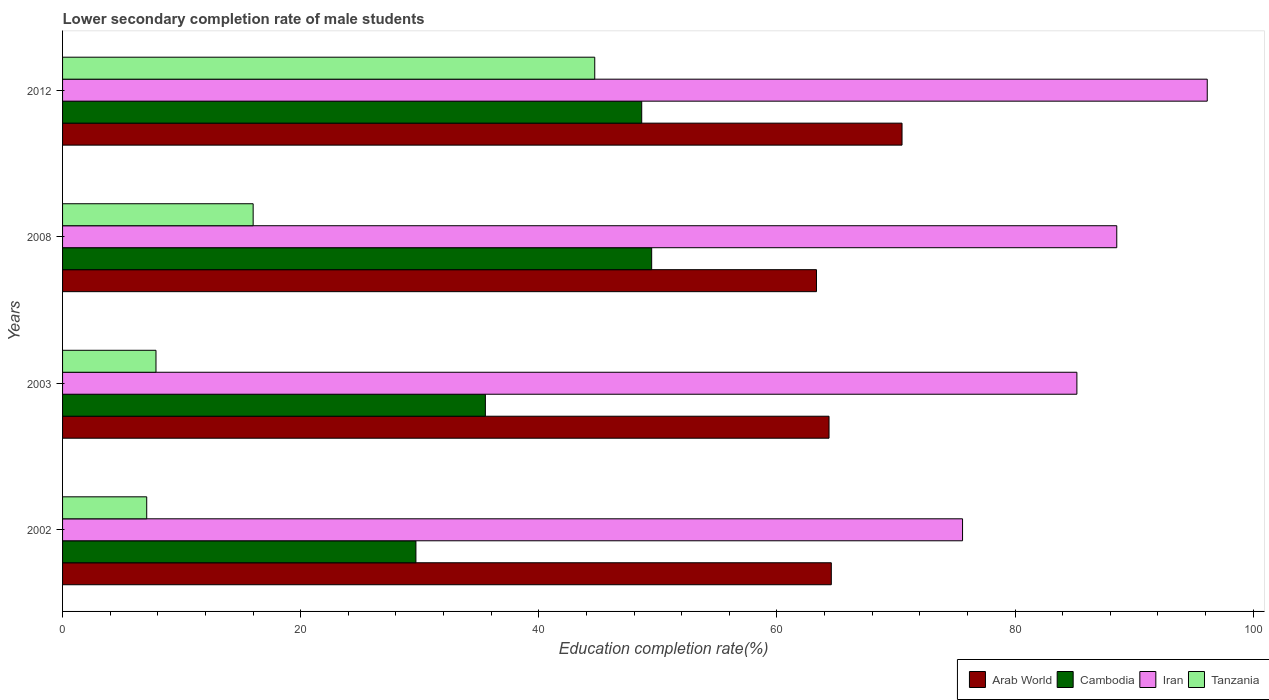Are the number of bars per tick equal to the number of legend labels?
Provide a succinct answer. Yes. How many bars are there on the 1st tick from the top?
Give a very brief answer. 4. How many bars are there on the 1st tick from the bottom?
Provide a succinct answer. 4. What is the label of the 3rd group of bars from the top?
Your answer should be compact. 2003. In how many cases, is the number of bars for a given year not equal to the number of legend labels?
Provide a succinct answer. 0. What is the lower secondary completion rate of male students in Cambodia in 2002?
Make the answer very short. 29.68. Across all years, what is the maximum lower secondary completion rate of male students in Iran?
Your answer should be compact. 96.14. Across all years, what is the minimum lower secondary completion rate of male students in Cambodia?
Provide a succinct answer. 29.68. In which year was the lower secondary completion rate of male students in Arab World minimum?
Ensure brevity in your answer.  2008. What is the total lower secondary completion rate of male students in Tanzania in the graph?
Keep it short and to the point. 75.62. What is the difference between the lower secondary completion rate of male students in Tanzania in 2003 and that in 2008?
Give a very brief answer. -8.16. What is the difference between the lower secondary completion rate of male students in Cambodia in 2012 and the lower secondary completion rate of male students in Iran in 2002?
Your answer should be compact. -26.95. What is the average lower secondary completion rate of male students in Iran per year?
Provide a short and direct response. 86.37. In the year 2008, what is the difference between the lower secondary completion rate of male students in Arab World and lower secondary completion rate of male students in Tanzania?
Offer a terse response. 47.31. What is the ratio of the lower secondary completion rate of male students in Iran in 2003 to that in 2008?
Keep it short and to the point. 0.96. What is the difference between the highest and the second highest lower secondary completion rate of male students in Tanzania?
Your answer should be compact. 28.69. What is the difference between the highest and the lowest lower secondary completion rate of male students in Iran?
Your answer should be compact. 20.55. Is it the case that in every year, the sum of the lower secondary completion rate of male students in Iran and lower secondary completion rate of male students in Arab World is greater than the sum of lower secondary completion rate of male students in Tanzania and lower secondary completion rate of male students in Cambodia?
Your answer should be compact. Yes. What does the 4th bar from the top in 2002 represents?
Ensure brevity in your answer.  Arab World. What does the 3rd bar from the bottom in 2003 represents?
Offer a terse response. Iran. How many bars are there?
Your answer should be very brief. 16. Are all the bars in the graph horizontal?
Offer a terse response. Yes. Does the graph contain any zero values?
Offer a terse response. No. Does the graph contain grids?
Give a very brief answer. No. Where does the legend appear in the graph?
Ensure brevity in your answer.  Bottom right. How are the legend labels stacked?
Ensure brevity in your answer.  Horizontal. What is the title of the graph?
Provide a succinct answer. Lower secondary completion rate of male students. Does "Pacific island small states" appear as one of the legend labels in the graph?
Provide a short and direct response. No. What is the label or title of the X-axis?
Your response must be concise. Education completion rate(%). What is the label or title of the Y-axis?
Offer a terse response. Years. What is the Education completion rate(%) in Arab World in 2002?
Give a very brief answer. 64.57. What is the Education completion rate(%) of Cambodia in 2002?
Offer a terse response. 29.68. What is the Education completion rate(%) in Iran in 2002?
Provide a short and direct response. 75.59. What is the Education completion rate(%) of Tanzania in 2002?
Offer a terse response. 7.07. What is the Education completion rate(%) in Arab World in 2003?
Your answer should be compact. 64.37. What is the Education completion rate(%) in Cambodia in 2003?
Offer a terse response. 35.51. What is the Education completion rate(%) of Iran in 2003?
Provide a succinct answer. 85.19. What is the Education completion rate(%) of Tanzania in 2003?
Provide a succinct answer. 7.85. What is the Education completion rate(%) in Arab World in 2008?
Offer a very short reply. 63.32. What is the Education completion rate(%) of Cambodia in 2008?
Your answer should be very brief. 49.48. What is the Education completion rate(%) of Iran in 2008?
Offer a terse response. 88.54. What is the Education completion rate(%) in Tanzania in 2008?
Make the answer very short. 16.01. What is the Education completion rate(%) in Arab World in 2012?
Ensure brevity in your answer.  70.51. What is the Education completion rate(%) of Cambodia in 2012?
Make the answer very short. 48.64. What is the Education completion rate(%) in Iran in 2012?
Provide a succinct answer. 96.14. What is the Education completion rate(%) in Tanzania in 2012?
Keep it short and to the point. 44.7. Across all years, what is the maximum Education completion rate(%) of Arab World?
Provide a succinct answer. 70.51. Across all years, what is the maximum Education completion rate(%) of Cambodia?
Make the answer very short. 49.48. Across all years, what is the maximum Education completion rate(%) of Iran?
Your answer should be very brief. 96.14. Across all years, what is the maximum Education completion rate(%) of Tanzania?
Your answer should be very brief. 44.7. Across all years, what is the minimum Education completion rate(%) in Arab World?
Your answer should be compact. 63.32. Across all years, what is the minimum Education completion rate(%) in Cambodia?
Make the answer very short. 29.68. Across all years, what is the minimum Education completion rate(%) in Iran?
Make the answer very short. 75.59. Across all years, what is the minimum Education completion rate(%) of Tanzania?
Your response must be concise. 7.07. What is the total Education completion rate(%) in Arab World in the graph?
Provide a succinct answer. 262.77. What is the total Education completion rate(%) in Cambodia in the graph?
Ensure brevity in your answer.  163.31. What is the total Education completion rate(%) in Iran in the graph?
Make the answer very short. 345.46. What is the total Education completion rate(%) of Tanzania in the graph?
Provide a short and direct response. 75.62. What is the difference between the Education completion rate(%) of Arab World in 2002 and that in 2003?
Offer a very short reply. 0.19. What is the difference between the Education completion rate(%) of Cambodia in 2002 and that in 2003?
Provide a succinct answer. -5.83. What is the difference between the Education completion rate(%) in Iran in 2002 and that in 2003?
Give a very brief answer. -9.6. What is the difference between the Education completion rate(%) in Tanzania in 2002 and that in 2003?
Your answer should be compact. -0.78. What is the difference between the Education completion rate(%) of Arab World in 2002 and that in 2008?
Your answer should be compact. 1.25. What is the difference between the Education completion rate(%) of Cambodia in 2002 and that in 2008?
Keep it short and to the point. -19.8. What is the difference between the Education completion rate(%) of Iran in 2002 and that in 2008?
Your answer should be very brief. -12.95. What is the difference between the Education completion rate(%) of Tanzania in 2002 and that in 2008?
Your answer should be compact. -8.94. What is the difference between the Education completion rate(%) of Arab World in 2002 and that in 2012?
Ensure brevity in your answer.  -5.94. What is the difference between the Education completion rate(%) of Cambodia in 2002 and that in 2012?
Offer a terse response. -18.96. What is the difference between the Education completion rate(%) in Iran in 2002 and that in 2012?
Provide a succinct answer. -20.55. What is the difference between the Education completion rate(%) of Tanzania in 2002 and that in 2012?
Your answer should be compact. -37.63. What is the difference between the Education completion rate(%) in Arab World in 2003 and that in 2008?
Make the answer very short. 1.05. What is the difference between the Education completion rate(%) of Cambodia in 2003 and that in 2008?
Make the answer very short. -13.97. What is the difference between the Education completion rate(%) of Iran in 2003 and that in 2008?
Keep it short and to the point. -3.35. What is the difference between the Education completion rate(%) of Tanzania in 2003 and that in 2008?
Your response must be concise. -8.16. What is the difference between the Education completion rate(%) of Arab World in 2003 and that in 2012?
Give a very brief answer. -6.13. What is the difference between the Education completion rate(%) of Cambodia in 2003 and that in 2012?
Your answer should be very brief. -13.13. What is the difference between the Education completion rate(%) of Iran in 2003 and that in 2012?
Offer a very short reply. -10.95. What is the difference between the Education completion rate(%) in Tanzania in 2003 and that in 2012?
Your response must be concise. -36.85. What is the difference between the Education completion rate(%) in Arab World in 2008 and that in 2012?
Your response must be concise. -7.18. What is the difference between the Education completion rate(%) of Cambodia in 2008 and that in 2012?
Your answer should be compact. 0.84. What is the difference between the Education completion rate(%) in Iran in 2008 and that in 2012?
Give a very brief answer. -7.6. What is the difference between the Education completion rate(%) in Tanzania in 2008 and that in 2012?
Your answer should be very brief. -28.69. What is the difference between the Education completion rate(%) in Arab World in 2002 and the Education completion rate(%) in Cambodia in 2003?
Provide a succinct answer. 29.06. What is the difference between the Education completion rate(%) of Arab World in 2002 and the Education completion rate(%) of Iran in 2003?
Your answer should be very brief. -20.63. What is the difference between the Education completion rate(%) in Arab World in 2002 and the Education completion rate(%) in Tanzania in 2003?
Ensure brevity in your answer.  56.72. What is the difference between the Education completion rate(%) of Cambodia in 2002 and the Education completion rate(%) of Iran in 2003?
Give a very brief answer. -55.51. What is the difference between the Education completion rate(%) in Cambodia in 2002 and the Education completion rate(%) in Tanzania in 2003?
Your answer should be compact. 21.83. What is the difference between the Education completion rate(%) in Iran in 2002 and the Education completion rate(%) in Tanzania in 2003?
Make the answer very short. 67.74. What is the difference between the Education completion rate(%) of Arab World in 2002 and the Education completion rate(%) of Cambodia in 2008?
Provide a succinct answer. 15.09. What is the difference between the Education completion rate(%) in Arab World in 2002 and the Education completion rate(%) in Iran in 2008?
Offer a very short reply. -23.98. What is the difference between the Education completion rate(%) of Arab World in 2002 and the Education completion rate(%) of Tanzania in 2008?
Your answer should be very brief. 48.56. What is the difference between the Education completion rate(%) in Cambodia in 2002 and the Education completion rate(%) in Iran in 2008?
Your response must be concise. -58.86. What is the difference between the Education completion rate(%) of Cambodia in 2002 and the Education completion rate(%) of Tanzania in 2008?
Offer a very short reply. 13.67. What is the difference between the Education completion rate(%) in Iran in 2002 and the Education completion rate(%) in Tanzania in 2008?
Provide a short and direct response. 59.58. What is the difference between the Education completion rate(%) in Arab World in 2002 and the Education completion rate(%) in Cambodia in 2012?
Ensure brevity in your answer.  15.92. What is the difference between the Education completion rate(%) of Arab World in 2002 and the Education completion rate(%) of Iran in 2012?
Offer a terse response. -31.58. What is the difference between the Education completion rate(%) in Arab World in 2002 and the Education completion rate(%) in Tanzania in 2012?
Provide a succinct answer. 19.87. What is the difference between the Education completion rate(%) of Cambodia in 2002 and the Education completion rate(%) of Iran in 2012?
Provide a short and direct response. -66.46. What is the difference between the Education completion rate(%) of Cambodia in 2002 and the Education completion rate(%) of Tanzania in 2012?
Offer a terse response. -15.02. What is the difference between the Education completion rate(%) in Iran in 2002 and the Education completion rate(%) in Tanzania in 2012?
Your answer should be very brief. 30.89. What is the difference between the Education completion rate(%) of Arab World in 2003 and the Education completion rate(%) of Cambodia in 2008?
Your answer should be very brief. 14.9. What is the difference between the Education completion rate(%) of Arab World in 2003 and the Education completion rate(%) of Iran in 2008?
Your response must be concise. -24.17. What is the difference between the Education completion rate(%) of Arab World in 2003 and the Education completion rate(%) of Tanzania in 2008?
Offer a very short reply. 48.37. What is the difference between the Education completion rate(%) in Cambodia in 2003 and the Education completion rate(%) in Iran in 2008?
Your response must be concise. -53.03. What is the difference between the Education completion rate(%) of Cambodia in 2003 and the Education completion rate(%) of Tanzania in 2008?
Keep it short and to the point. 19.5. What is the difference between the Education completion rate(%) of Iran in 2003 and the Education completion rate(%) of Tanzania in 2008?
Ensure brevity in your answer.  69.18. What is the difference between the Education completion rate(%) of Arab World in 2003 and the Education completion rate(%) of Cambodia in 2012?
Keep it short and to the point. 15.73. What is the difference between the Education completion rate(%) in Arab World in 2003 and the Education completion rate(%) in Iran in 2012?
Ensure brevity in your answer.  -31.77. What is the difference between the Education completion rate(%) of Arab World in 2003 and the Education completion rate(%) of Tanzania in 2012?
Your answer should be compact. 19.68. What is the difference between the Education completion rate(%) in Cambodia in 2003 and the Education completion rate(%) in Iran in 2012?
Ensure brevity in your answer.  -60.63. What is the difference between the Education completion rate(%) in Cambodia in 2003 and the Education completion rate(%) in Tanzania in 2012?
Give a very brief answer. -9.19. What is the difference between the Education completion rate(%) in Iran in 2003 and the Education completion rate(%) in Tanzania in 2012?
Provide a succinct answer. 40.49. What is the difference between the Education completion rate(%) in Arab World in 2008 and the Education completion rate(%) in Cambodia in 2012?
Your answer should be very brief. 14.68. What is the difference between the Education completion rate(%) in Arab World in 2008 and the Education completion rate(%) in Iran in 2012?
Provide a short and direct response. -32.82. What is the difference between the Education completion rate(%) in Arab World in 2008 and the Education completion rate(%) in Tanzania in 2012?
Make the answer very short. 18.62. What is the difference between the Education completion rate(%) of Cambodia in 2008 and the Education completion rate(%) of Iran in 2012?
Ensure brevity in your answer.  -46.66. What is the difference between the Education completion rate(%) of Cambodia in 2008 and the Education completion rate(%) of Tanzania in 2012?
Give a very brief answer. 4.78. What is the difference between the Education completion rate(%) of Iran in 2008 and the Education completion rate(%) of Tanzania in 2012?
Offer a terse response. 43.84. What is the average Education completion rate(%) of Arab World per year?
Keep it short and to the point. 65.69. What is the average Education completion rate(%) in Cambodia per year?
Ensure brevity in your answer.  40.83. What is the average Education completion rate(%) in Iran per year?
Provide a short and direct response. 86.37. What is the average Education completion rate(%) in Tanzania per year?
Make the answer very short. 18.9. In the year 2002, what is the difference between the Education completion rate(%) in Arab World and Education completion rate(%) in Cambodia?
Give a very brief answer. 34.89. In the year 2002, what is the difference between the Education completion rate(%) of Arab World and Education completion rate(%) of Iran?
Give a very brief answer. -11.02. In the year 2002, what is the difference between the Education completion rate(%) of Arab World and Education completion rate(%) of Tanzania?
Your answer should be compact. 57.5. In the year 2002, what is the difference between the Education completion rate(%) of Cambodia and Education completion rate(%) of Iran?
Offer a terse response. -45.91. In the year 2002, what is the difference between the Education completion rate(%) of Cambodia and Education completion rate(%) of Tanzania?
Your response must be concise. 22.61. In the year 2002, what is the difference between the Education completion rate(%) in Iran and Education completion rate(%) in Tanzania?
Keep it short and to the point. 68.52. In the year 2003, what is the difference between the Education completion rate(%) in Arab World and Education completion rate(%) in Cambodia?
Give a very brief answer. 28.86. In the year 2003, what is the difference between the Education completion rate(%) of Arab World and Education completion rate(%) of Iran?
Provide a short and direct response. -20.82. In the year 2003, what is the difference between the Education completion rate(%) of Arab World and Education completion rate(%) of Tanzania?
Offer a very short reply. 56.53. In the year 2003, what is the difference between the Education completion rate(%) of Cambodia and Education completion rate(%) of Iran?
Offer a very short reply. -49.68. In the year 2003, what is the difference between the Education completion rate(%) in Cambodia and Education completion rate(%) in Tanzania?
Make the answer very short. 27.66. In the year 2003, what is the difference between the Education completion rate(%) of Iran and Education completion rate(%) of Tanzania?
Your answer should be very brief. 77.35. In the year 2008, what is the difference between the Education completion rate(%) in Arab World and Education completion rate(%) in Cambodia?
Ensure brevity in your answer.  13.84. In the year 2008, what is the difference between the Education completion rate(%) of Arab World and Education completion rate(%) of Iran?
Give a very brief answer. -25.22. In the year 2008, what is the difference between the Education completion rate(%) in Arab World and Education completion rate(%) in Tanzania?
Make the answer very short. 47.31. In the year 2008, what is the difference between the Education completion rate(%) in Cambodia and Education completion rate(%) in Iran?
Your answer should be very brief. -39.06. In the year 2008, what is the difference between the Education completion rate(%) in Cambodia and Education completion rate(%) in Tanzania?
Offer a terse response. 33.47. In the year 2008, what is the difference between the Education completion rate(%) of Iran and Education completion rate(%) of Tanzania?
Provide a short and direct response. 72.53. In the year 2012, what is the difference between the Education completion rate(%) in Arab World and Education completion rate(%) in Cambodia?
Your answer should be compact. 21.86. In the year 2012, what is the difference between the Education completion rate(%) of Arab World and Education completion rate(%) of Iran?
Provide a succinct answer. -25.64. In the year 2012, what is the difference between the Education completion rate(%) of Arab World and Education completion rate(%) of Tanzania?
Your answer should be compact. 25.81. In the year 2012, what is the difference between the Education completion rate(%) of Cambodia and Education completion rate(%) of Iran?
Keep it short and to the point. -47.5. In the year 2012, what is the difference between the Education completion rate(%) of Cambodia and Education completion rate(%) of Tanzania?
Give a very brief answer. 3.95. In the year 2012, what is the difference between the Education completion rate(%) in Iran and Education completion rate(%) in Tanzania?
Provide a short and direct response. 51.44. What is the ratio of the Education completion rate(%) in Arab World in 2002 to that in 2003?
Keep it short and to the point. 1. What is the ratio of the Education completion rate(%) of Cambodia in 2002 to that in 2003?
Your answer should be very brief. 0.84. What is the ratio of the Education completion rate(%) in Iran in 2002 to that in 2003?
Your answer should be compact. 0.89. What is the ratio of the Education completion rate(%) of Tanzania in 2002 to that in 2003?
Your answer should be compact. 0.9. What is the ratio of the Education completion rate(%) in Arab World in 2002 to that in 2008?
Offer a very short reply. 1.02. What is the ratio of the Education completion rate(%) in Cambodia in 2002 to that in 2008?
Provide a short and direct response. 0.6. What is the ratio of the Education completion rate(%) of Iran in 2002 to that in 2008?
Provide a short and direct response. 0.85. What is the ratio of the Education completion rate(%) of Tanzania in 2002 to that in 2008?
Offer a very short reply. 0.44. What is the ratio of the Education completion rate(%) of Arab World in 2002 to that in 2012?
Give a very brief answer. 0.92. What is the ratio of the Education completion rate(%) in Cambodia in 2002 to that in 2012?
Your answer should be very brief. 0.61. What is the ratio of the Education completion rate(%) of Iran in 2002 to that in 2012?
Provide a succinct answer. 0.79. What is the ratio of the Education completion rate(%) of Tanzania in 2002 to that in 2012?
Your response must be concise. 0.16. What is the ratio of the Education completion rate(%) of Arab World in 2003 to that in 2008?
Ensure brevity in your answer.  1.02. What is the ratio of the Education completion rate(%) in Cambodia in 2003 to that in 2008?
Provide a succinct answer. 0.72. What is the ratio of the Education completion rate(%) of Iran in 2003 to that in 2008?
Provide a short and direct response. 0.96. What is the ratio of the Education completion rate(%) of Tanzania in 2003 to that in 2008?
Provide a short and direct response. 0.49. What is the ratio of the Education completion rate(%) in Arab World in 2003 to that in 2012?
Ensure brevity in your answer.  0.91. What is the ratio of the Education completion rate(%) in Cambodia in 2003 to that in 2012?
Provide a short and direct response. 0.73. What is the ratio of the Education completion rate(%) of Iran in 2003 to that in 2012?
Make the answer very short. 0.89. What is the ratio of the Education completion rate(%) in Tanzania in 2003 to that in 2012?
Keep it short and to the point. 0.18. What is the ratio of the Education completion rate(%) of Arab World in 2008 to that in 2012?
Give a very brief answer. 0.9. What is the ratio of the Education completion rate(%) of Cambodia in 2008 to that in 2012?
Give a very brief answer. 1.02. What is the ratio of the Education completion rate(%) of Iran in 2008 to that in 2012?
Your answer should be very brief. 0.92. What is the ratio of the Education completion rate(%) in Tanzania in 2008 to that in 2012?
Offer a very short reply. 0.36. What is the difference between the highest and the second highest Education completion rate(%) of Arab World?
Provide a succinct answer. 5.94. What is the difference between the highest and the second highest Education completion rate(%) of Cambodia?
Give a very brief answer. 0.84. What is the difference between the highest and the second highest Education completion rate(%) of Iran?
Offer a very short reply. 7.6. What is the difference between the highest and the second highest Education completion rate(%) of Tanzania?
Provide a succinct answer. 28.69. What is the difference between the highest and the lowest Education completion rate(%) of Arab World?
Offer a very short reply. 7.18. What is the difference between the highest and the lowest Education completion rate(%) of Cambodia?
Provide a short and direct response. 19.8. What is the difference between the highest and the lowest Education completion rate(%) of Iran?
Your answer should be very brief. 20.55. What is the difference between the highest and the lowest Education completion rate(%) of Tanzania?
Your response must be concise. 37.63. 